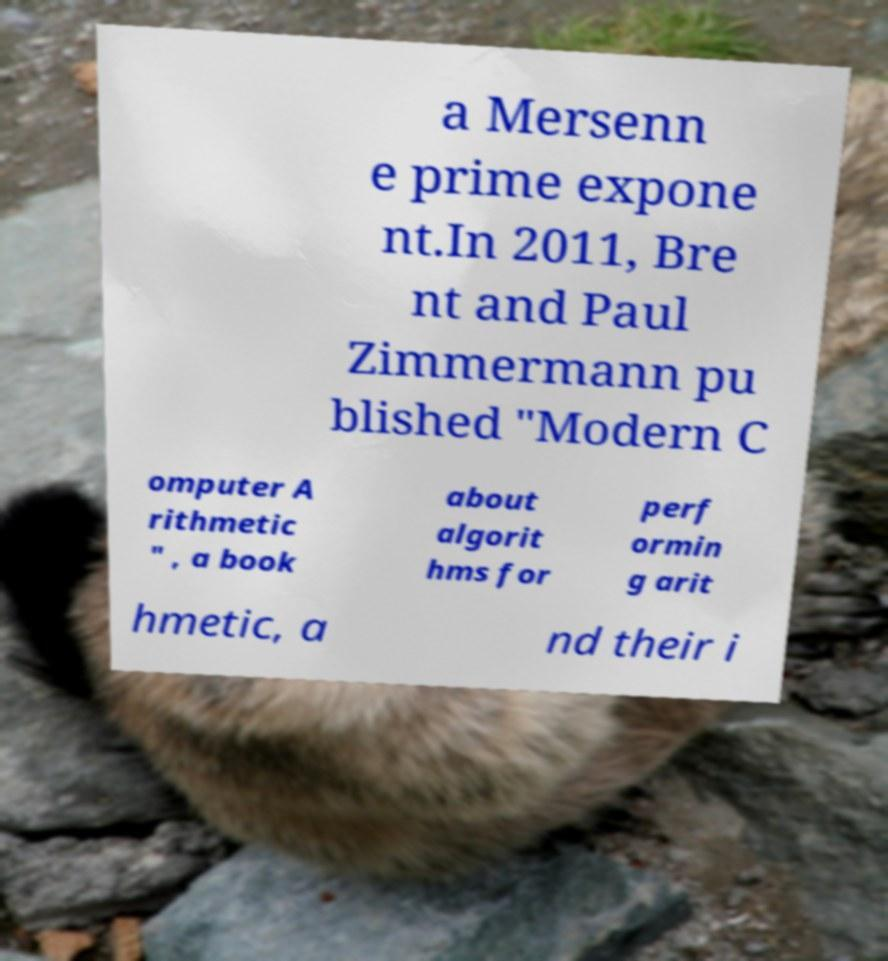I need the written content from this picture converted into text. Can you do that? a Mersenn e prime expone nt.In 2011, Bre nt and Paul Zimmermann pu blished "Modern C omputer A rithmetic " , a book about algorit hms for perf ormin g arit hmetic, a nd their i 